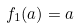Convert formula to latex. <formula><loc_0><loc_0><loc_500><loc_500>f _ { 1 } ( a ) = a</formula> 